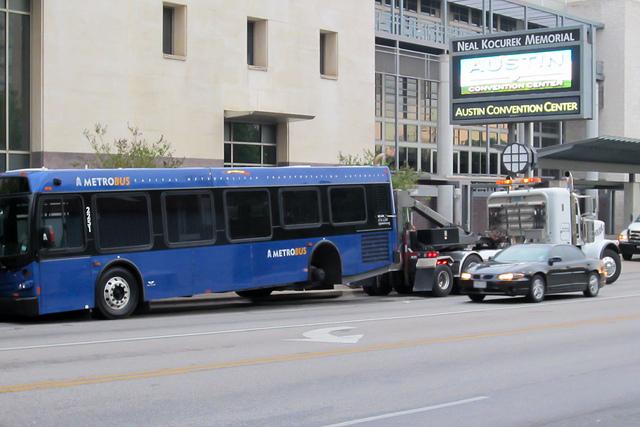What is written on the side of the bus?
Answer briefly. Metrobus. How many tires are on the bus?
Quick response, please. 3. What color is the bus?
Answer briefly. Blue. What color are the buses?
Be succinct. Blue. What vehicle is being towed?
Keep it brief. Bus. Is there writing on the windows?
Give a very brief answer. No. What building is the cars parked outside of?
Short answer required. Convention center. What form of entertainment is advertised?
Concise answer only. Convention center. What color is the car?
Write a very short answer. Black. Is this a station?
Quick response, please. No. 